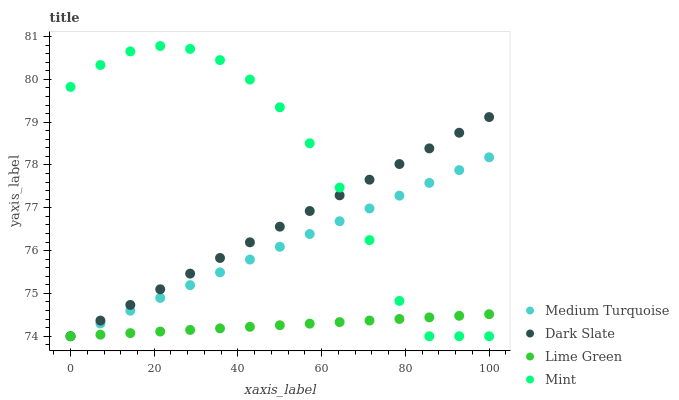Does Lime Green have the minimum area under the curve?
Answer yes or no. Yes. Does Mint have the maximum area under the curve?
Answer yes or no. Yes. Does Mint have the minimum area under the curve?
Answer yes or no. No. Does Lime Green have the maximum area under the curve?
Answer yes or no. No. Is Dark Slate the smoothest?
Answer yes or no. Yes. Is Mint the roughest?
Answer yes or no. Yes. Is Lime Green the smoothest?
Answer yes or no. No. Is Lime Green the roughest?
Answer yes or no. No. Does Dark Slate have the lowest value?
Answer yes or no. Yes. Does Mint have the highest value?
Answer yes or no. Yes. Does Lime Green have the highest value?
Answer yes or no. No. Does Dark Slate intersect Medium Turquoise?
Answer yes or no. Yes. Is Dark Slate less than Medium Turquoise?
Answer yes or no. No. Is Dark Slate greater than Medium Turquoise?
Answer yes or no. No. 